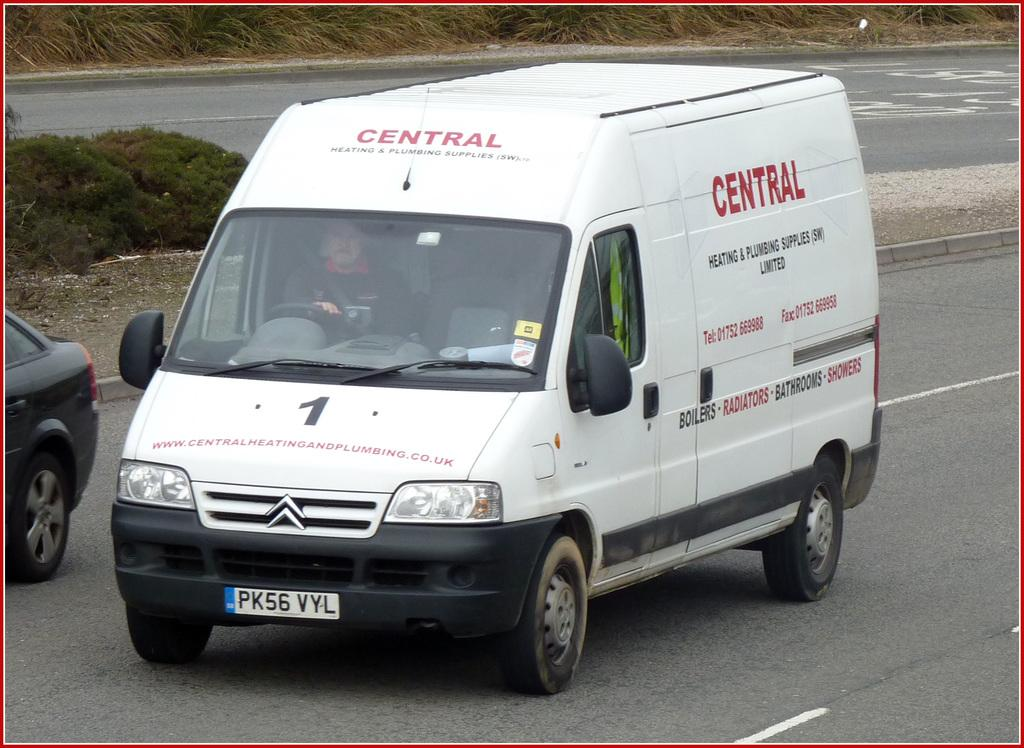What type of vehicle is in the image? There is a van in the image. What color is the van? The van is white. Can you describe the person inside the van? The facts do not provide any information about the person inside the van. What is written on the van? The van has some text on it. What else can be seen on the road in the image? There is another car on the road in the image. What type of vegetation is visible behind the van? There is grass visible behind the van. What type of dock can be seen near the van in the image? There is no dock present in the image; it features a white van, another car, and grass. What type of milk is being delivered by the van in the image? There is no indication in the image that the van is delivering milk or any other product. 